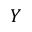<formula> <loc_0><loc_0><loc_500><loc_500>Y</formula> 